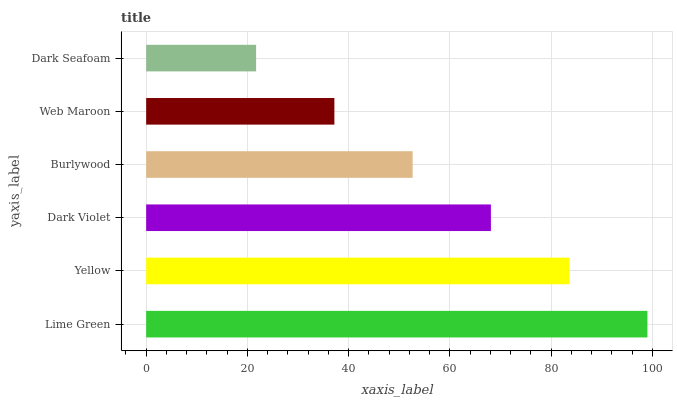Is Dark Seafoam the minimum?
Answer yes or no. Yes. Is Lime Green the maximum?
Answer yes or no. Yes. Is Yellow the minimum?
Answer yes or no. No. Is Yellow the maximum?
Answer yes or no. No. Is Lime Green greater than Yellow?
Answer yes or no. Yes. Is Yellow less than Lime Green?
Answer yes or no. Yes. Is Yellow greater than Lime Green?
Answer yes or no. No. Is Lime Green less than Yellow?
Answer yes or no. No. Is Dark Violet the high median?
Answer yes or no. Yes. Is Burlywood the low median?
Answer yes or no. Yes. Is Lime Green the high median?
Answer yes or no. No. Is Lime Green the low median?
Answer yes or no. No. 